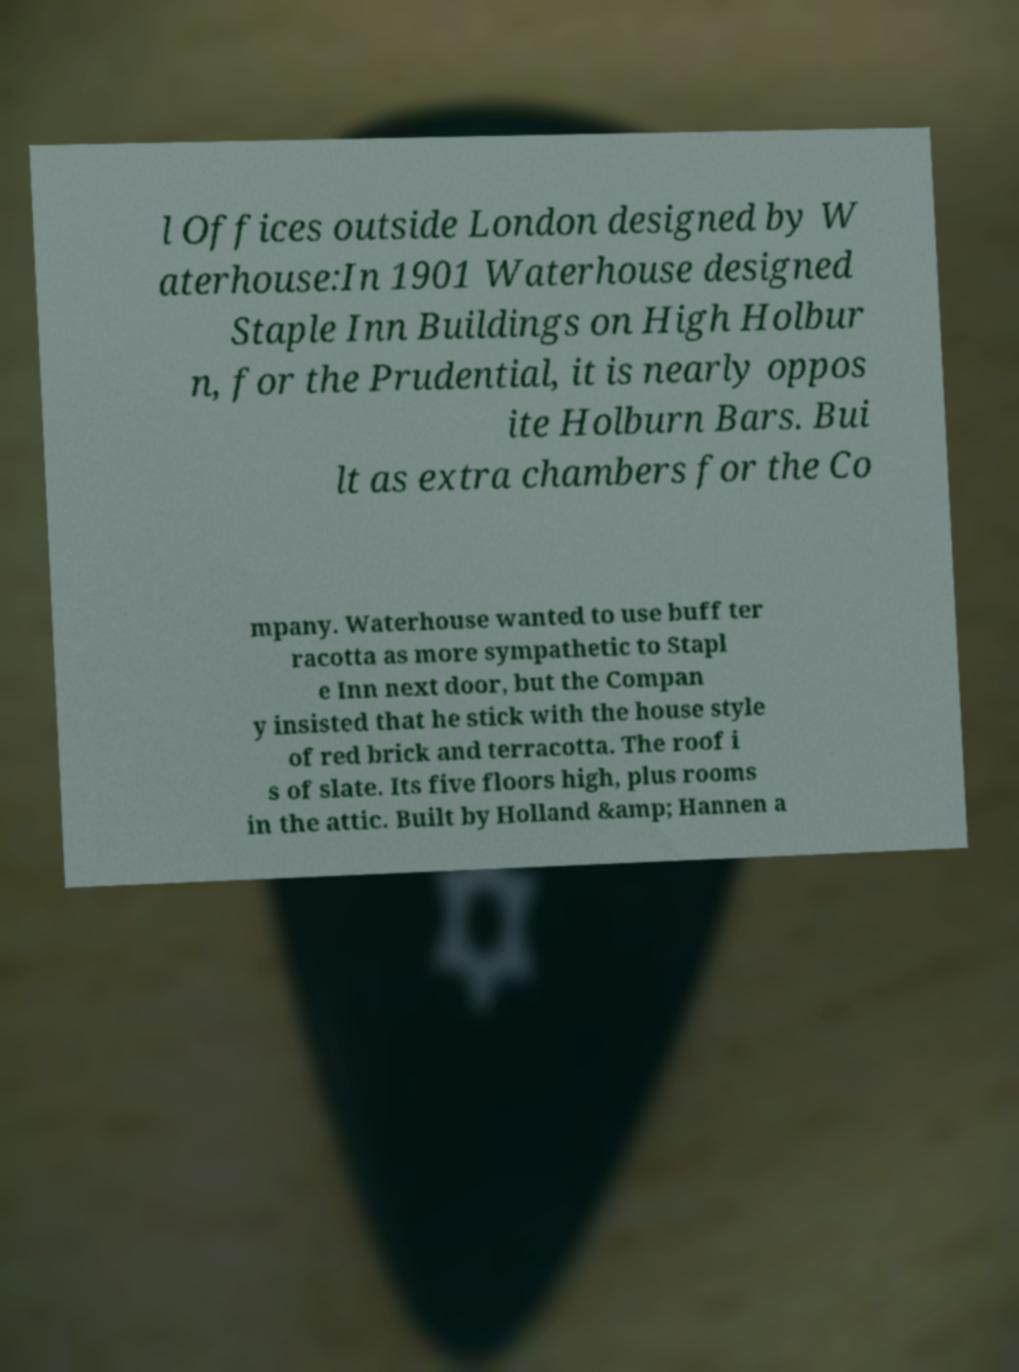Could you extract and type out the text from this image? l Offices outside London designed by W aterhouse:In 1901 Waterhouse designed Staple Inn Buildings on High Holbur n, for the Prudential, it is nearly oppos ite Holburn Bars. Bui lt as extra chambers for the Co mpany. Waterhouse wanted to use buff ter racotta as more sympathetic to Stapl e Inn next door, but the Compan y insisted that he stick with the house style of red brick and terracotta. The roof i s of slate. Its five floors high, plus rooms in the attic. Built by Holland &amp; Hannen a 